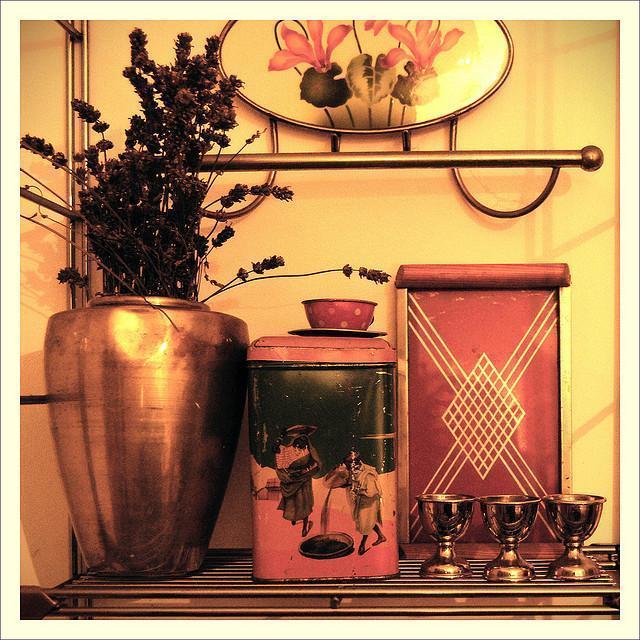How many objects are in the picture?
Give a very brief answer. 8. How many wine glasses are there?
Give a very brief answer. 2. How many cups are in the picture?
Give a very brief answer. 2. 